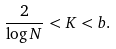<formula> <loc_0><loc_0><loc_500><loc_500>\frac { 2 } { \log N } < K < b .</formula> 